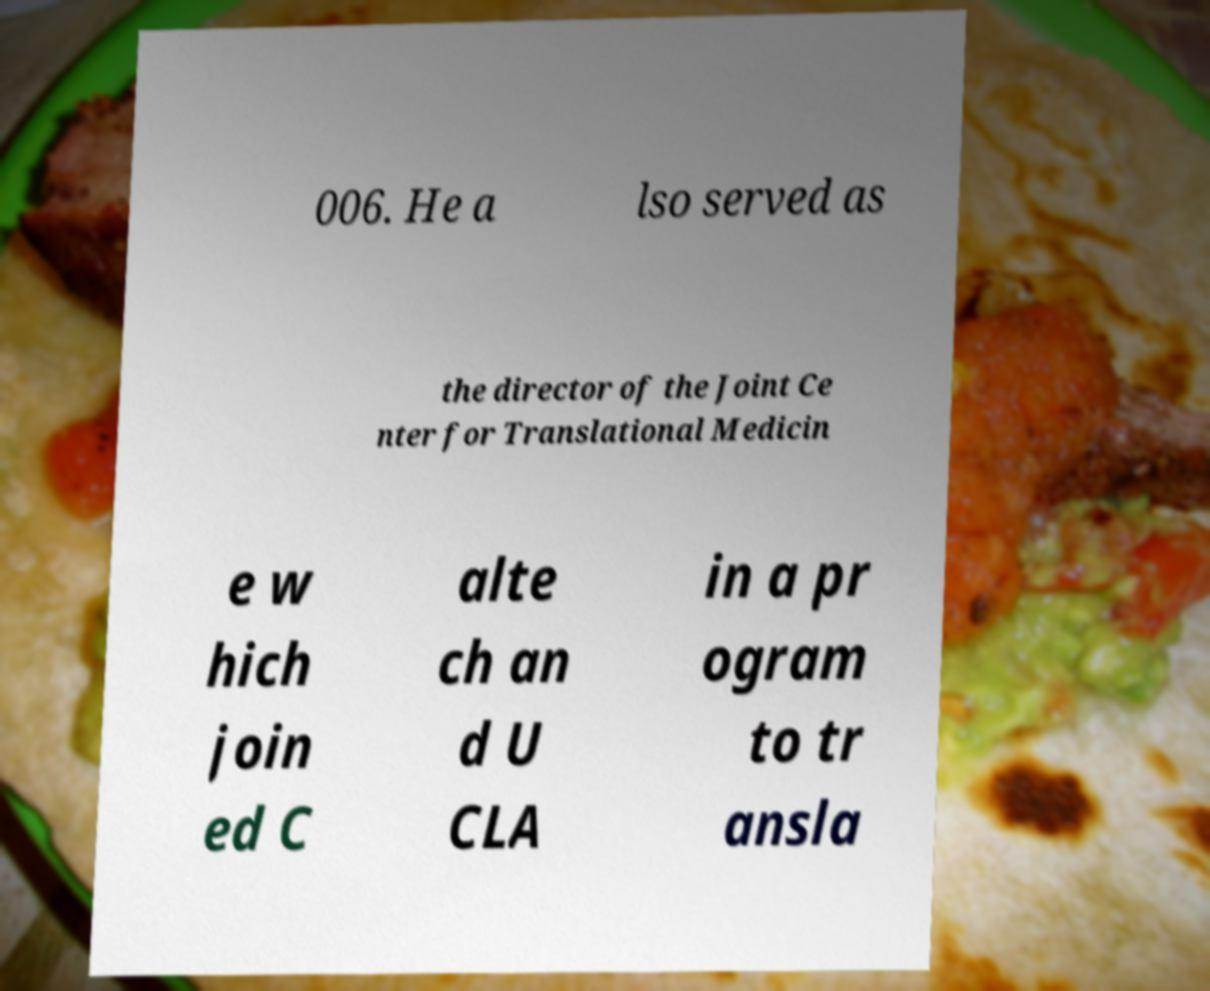For documentation purposes, I need the text within this image transcribed. Could you provide that? 006. He a lso served as the director of the Joint Ce nter for Translational Medicin e w hich join ed C alte ch an d U CLA in a pr ogram to tr ansla 